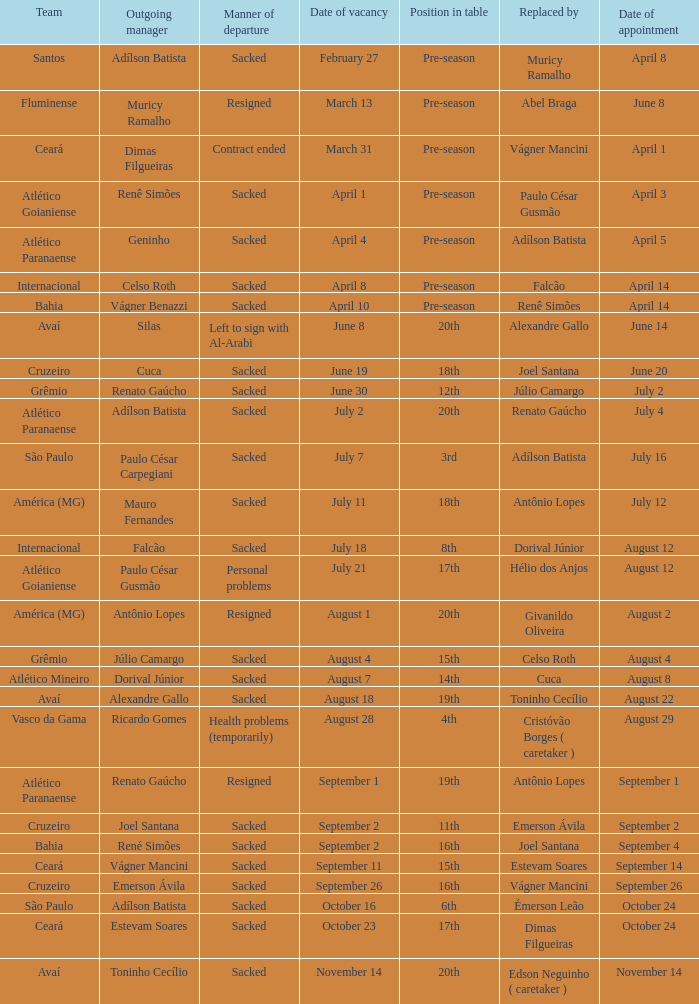What team hired Renato Gaúcho? Atlético Paranaense. 